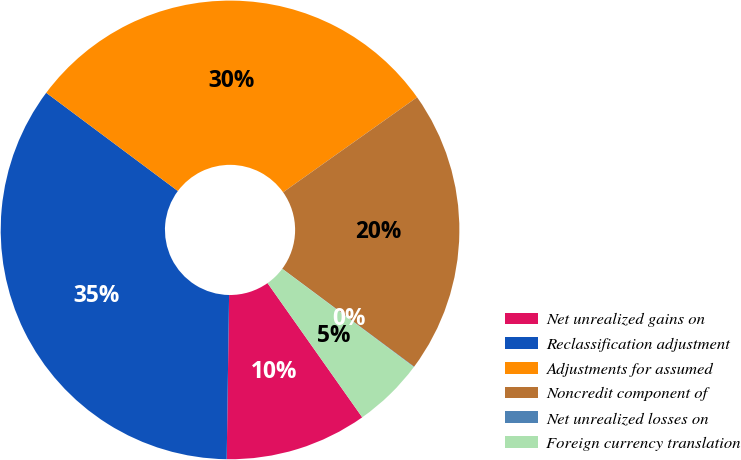<chart> <loc_0><loc_0><loc_500><loc_500><pie_chart><fcel>Net unrealized gains on<fcel>Reclassification adjustment<fcel>Adjustments for assumed<fcel>Noncredit component of<fcel>Net unrealized losses on<fcel>Foreign currency translation<nl><fcel>10.01%<fcel>34.97%<fcel>29.98%<fcel>19.99%<fcel>0.03%<fcel>5.02%<nl></chart> 